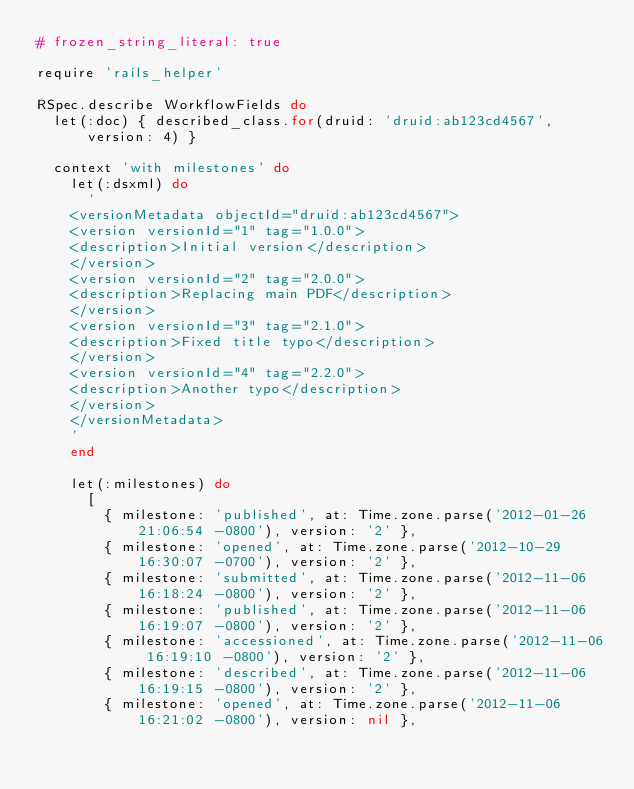Convert code to text. <code><loc_0><loc_0><loc_500><loc_500><_Ruby_># frozen_string_literal: true

require 'rails_helper'

RSpec.describe WorkflowFields do
  let(:doc) { described_class.for(druid: 'druid:ab123cd4567', version: 4) }

  context 'with milestones' do
    let(:dsxml) do
      '
    <versionMetadata objectId="druid:ab123cd4567">
    <version versionId="1" tag="1.0.0">
    <description>Initial version</description>
    </version>
    <version versionId="2" tag="2.0.0">
    <description>Replacing main PDF</description>
    </version>
    <version versionId="3" tag="2.1.0">
    <description>Fixed title typo</description>
    </version>
    <version versionId="4" tag="2.2.0">
    <description>Another typo</description>
    </version>
    </versionMetadata>
    '
    end

    let(:milestones) do
      [
        { milestone: 'published', at: Time.zone.parse('2012-01-26 21:06:54 -0800'), version: '2' },
        { milestone: 'opened', at: Time.zone.parse('2012-10-29 16:30:07 -0700'), version: '2' },
        { milestone: 'submitted', at: Time.zone.parse('2012-11-06 16:18:24 -0800'), version: '2' },
        { milestone: 'published', at: Time.zone.parse('2012-11-06 16:19:07 -0800'), version: '2' },
        { milestone: 'accessioned', at: Time.zone.parse('2012-11-06 16:19:10 -0800'), version: '2' },
        { milestone: 'described', at: Time.zone.parse('2012-11-06 16:19:15 -0800'), version: '2' },
        { milestone: 'opened', at: Time.zone.parse('2012-11-06 16:21:02 -0800'), version: nil },</code> 